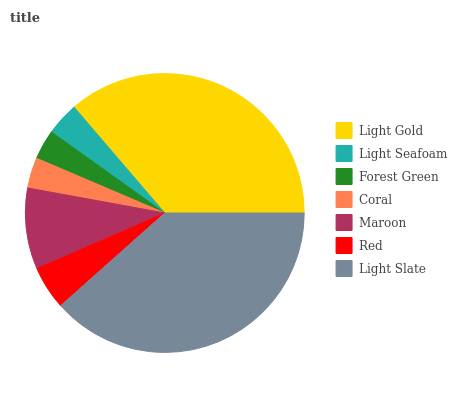Is Forest Green the minimum?
Answer yes or no. Yes. Is Light Slate the maximum?
Answer yes or no. Yes. Is Light Seafoam the minimum?
Answer yes or no. No. Is Light Seafoam the maximum?
Answer yes or no. No. Is Light Gold greater than Light Seafoam?
Answer yes or no. Yes. Is Light Seafoam less than Light Gold?
Answer yes or no. Yes. Is Light Seafoam greater than Light Gold?
Answer yes or no. No. Is Light Gold less than Light Seafoam?
Answer yes or no. No. Is Red the high median?
Answer yes or no. Yes. Is Red the low median?
Answer yes or no. Yes. Is Light Slate the high median?
Answer yes or no. No. Is Coral the low median?
Answer yes or no. No. 